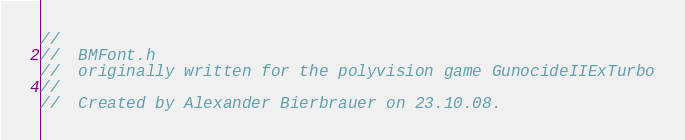Convert code to text. <code><loc_0><loc_0><loc_500><loc_500><_ObjectiveC_>//
//  BMFont.h
//  originally written for the polyvision game GunocideIIExTurbo
//
//  Created by Alexander Bierbrauer on 23.10.08.</code> 